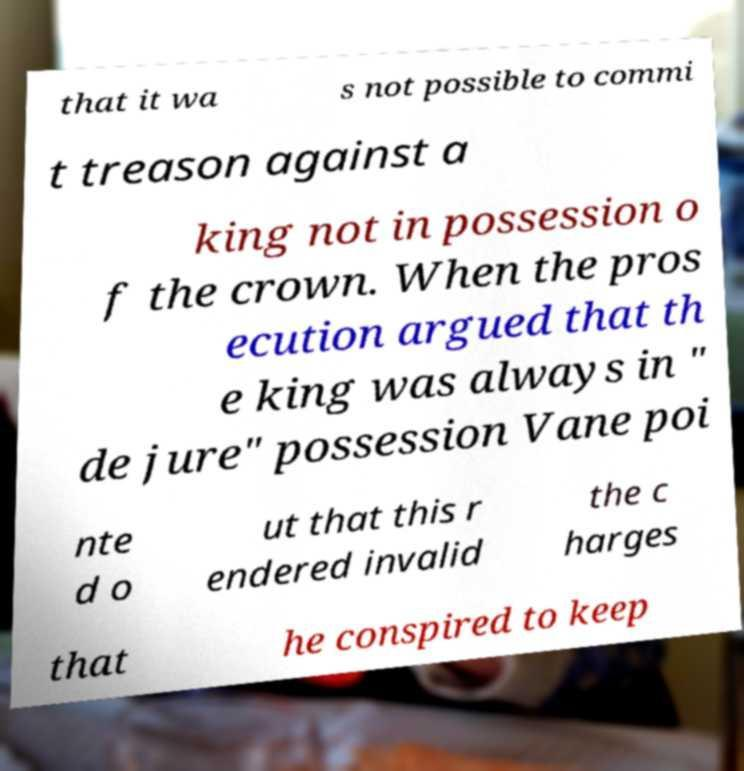What messages or text are displayed in this image? I need them in a readable, typed format. that it wa s not possible to commi t treason against a king not in possession o f the crown. When the pros ecution argued that th e king was always in " de jure" possession Vane poi nte d o ut that this r endered invalid the c harges that he conspired to keep 